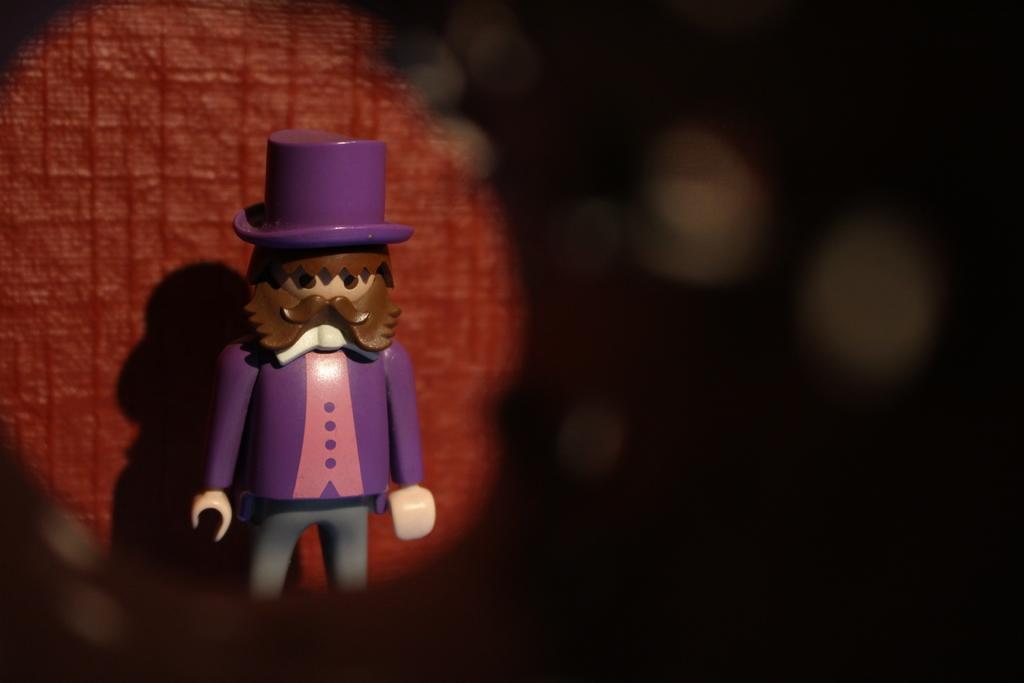Describe this image in one or two sentences. In this image, we can see a toy and in the background, there is a wall and some part of it is blurry. 